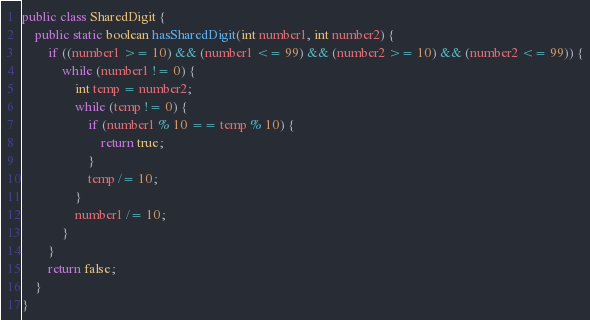<code> <loc_0><loc_0><loc_500><loc_500><_Java_>public class SharedDigit {
    public static boolean hasSharedDigit(int number1, int number2) {
        if ((number1 >= 10) && (number1 <= 99) && (number2 >= 10) && (number2 <= 99)) {
            while (number1 != 0) {
                int temp = number2;
                while (temp != 0) {
                    if (number1 % 10 == temp % 10) {
                        return true;
                    }
                    temp /= 10;
                }
                number1 /= 10;
            }
        }
        return false;
    }
}
</code> 